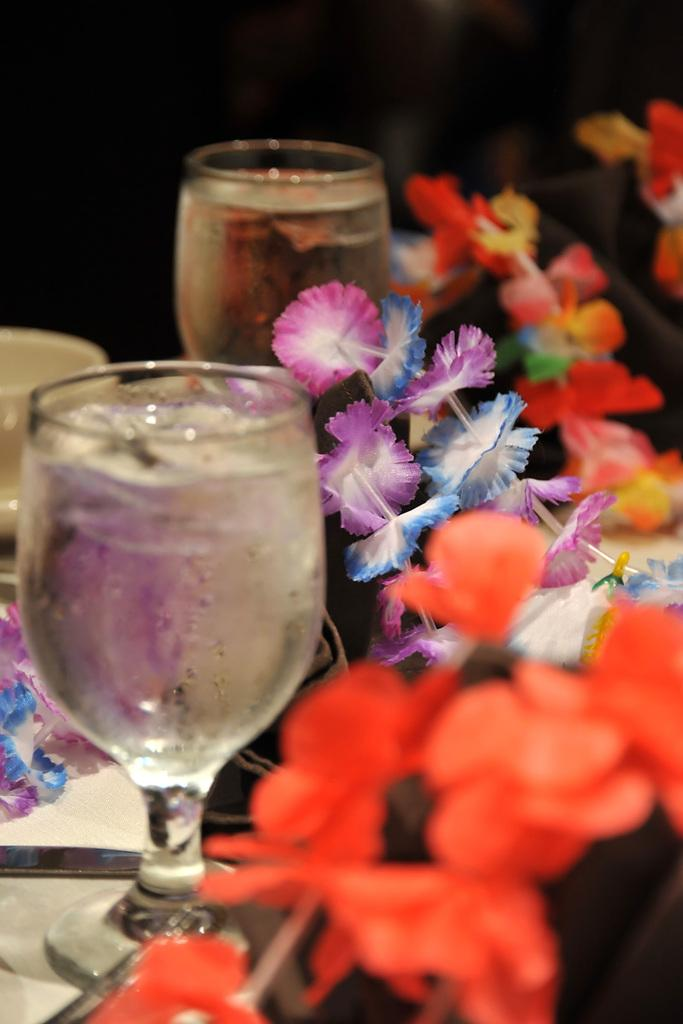What type of container is visible in the image? There is a glass and a cup in the image. What is inside the glass? The glasses are filled with a drink. What decorative items can be seen in the image? There are artificial flowers in the image. What utensil is placed on a plate in the image? There is a knife on a plate in the image. Can you describe the background of the image? The background of the image is blurry. Where is the pan located in the image? There is no pan present in the image. What type of garden can be seen in the image? There is no garden present in the image. 